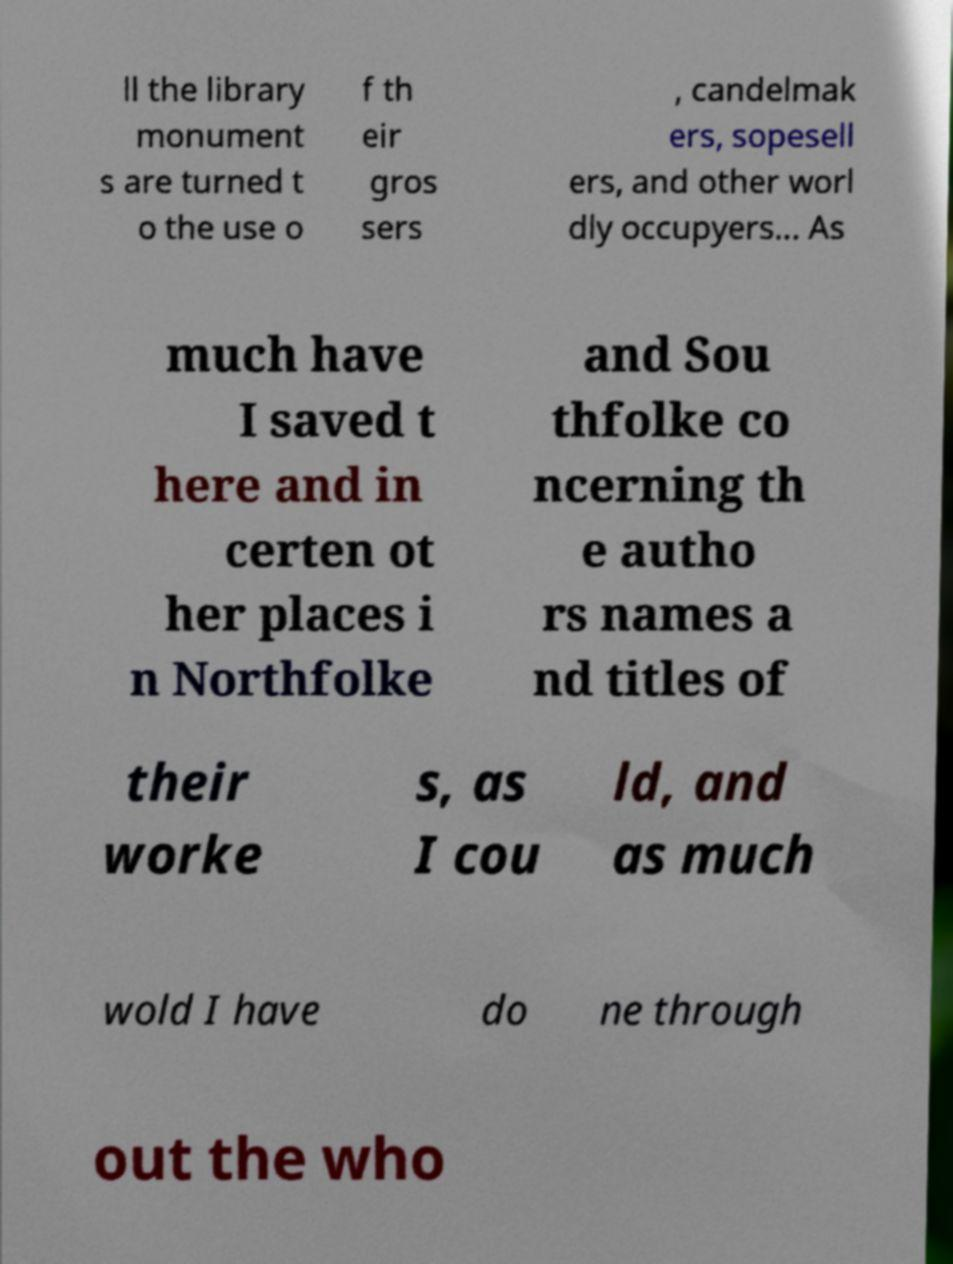What messages or text are displayed in this image? I need them in a readable, typed format. ll the library monument s are turned t o the use o f th eir gros sers , candelmak ers, sopesell ers, and other worl dly occupyers... As much have I saved t here and in certen ot her places i n Northfolke and Sou thfolke co ncerning th e autho rs names a nd titles of their worke s, as I cou ld, and as much wold I have do ne through out the who 